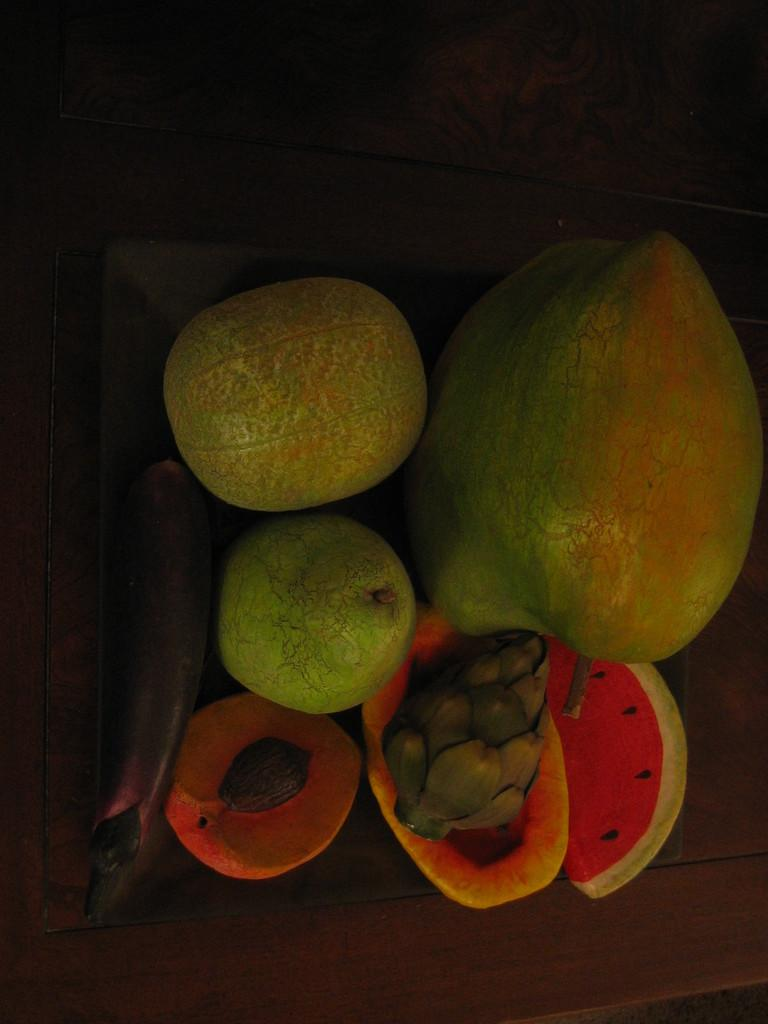What type of food can be seen in the image? There are fruits in the image. What colors are the fruits in the image? The fruits have red, orange, brown, and green colors. How would you describe the background of the image? The background of the image is dark. Can you see any vegetables being covered by mist in the image? There are no vegetables or mist present in the image; it only features fruits with various colors against a dark background. 